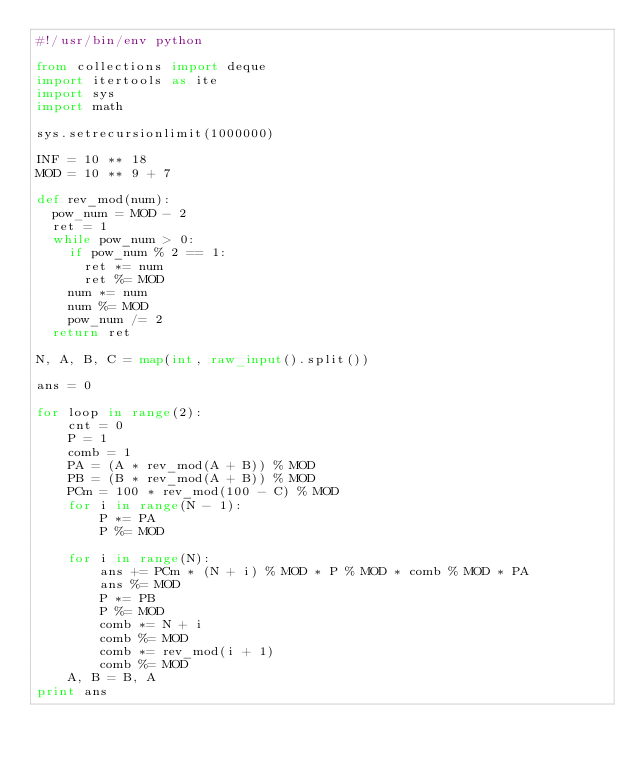<code> <loc_0><loc_0><loc_500><loc_500><_Python_>#!/usr/bin/env python

from collections import deque
import itertools as ite
import sys
import math

sys.setrecursionlimit(1000000)

INF = 10 ** 18
MOD = 10 ** 9 + 7

def rev_mod(num):
	pow_num = MOD - 2
	ret = 1
	while pow_num > 0:
		if pow_num % 2 == 1:
			ret *= num
			ret %= MOD
		num *= num
		num %= MOD
		pow_num /= 2
	return ret

N, A, B, C = map(int, raw_input().split())

ans = 0

for loop in range(2):
    cnt = 0
    P = 1
    comb = 1
    PA = (A * rev_mod(A + B)) % MOD
    PB = (B * rev_mod(A + B)) % MOD
    PCm = 100 * rev_mod(100 - C) % MOD
    for i in range(N - 1):
        P *= PA
        P %= MOD

    for i in range(N):
        ans += PCm * (N + i) % MOD * P % MOD * comb % MOD * PA
        ans %= MOD
        P *= PB
        P %= MOD
        comb *= N + i
        comb %= MOD
        comb *= rev_mod(i + 1)
        comb %= MOD
    A, B = B, A
print ans</code> 